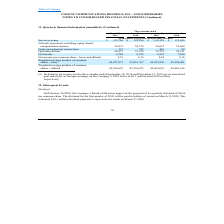From Cogent Communications Group's financial document, What are the respective service revenue at March 31 and June 30, 2018? The document shows two values: $128,706 and $129,296 (in thousands). From the document: "pt share and per share amounts) Service revenue $ 128,706 $ 129,296 $ 130,139 $ 132,049 Network operations, including equity-based compensation expens..." Also, What are the respective service revenue at June 30 and September 30, 2018? The document shows two values: $129,296 and $130,139 (in thousands). From the document: "re amounts) Service revenue $ 128,706 $ 129,296 $ 130,139 $ 132,049 Network operations, including equity-based compensation expense 54,875 54,379 54,6..." Also, What are the respective service revenue at September 30 and December 31, 2018? The document shows two values: $130,139 and $132,049 (in thousands). From the document: "re amounts) Service revenue $ 128,706 $ 129,296 $ 130,139 $ 132,049 Network operations, including equity-based compensation expense 54,875 54,379 54,6..." Also, can you calculate: What is the total service revenue at March 31 and June 30, 2018? Based on the calculation: ($128,706 + $129,296) , the result is 258002 (in thousands). This is based on the information: "pt share and per share amounts) Service revenue $ 128,706 $ 129,296 $ 130,139 $ 132,049 Network operations, including equity-based compensation expense 54,87 nd per share amounts) Service revenue $ 12..." The key data points involved are: 128,706, 129,296. Also, can you calculate: What is the average service revenue at June 30 and September 30, 2018? To answer this question, I need to perform calculations using the financial data. The calculation is: ($129,296 + $130,139)/2 , which equals 129717.5 (in thousands). This is based on the information: "re amounts) Service revenue $ 128,706 $ 129,296 $ 130,139 $ 132,049 Network operations, including equity-based compensation expense 54,875 54,379 54,615 55,6 nd per share amounts) Service revenue $ 12..." The key data points involved are: 129,296, 130,139. Also, can you calculate: What is the percentage change in the service revenue between September 30 and December 31, 2018? To answer this question, I need to perform calculations using the financial data. The calculation is: ($132,049 - $130,139)/$130,139 , which equals 1.47 (percentage). This is based on the information: "re amounts) Service revenue $ 128,706 $ 129,296 $ 130,139 $ 132,049 Network operations, including equity-based compensation expense 54,875 54,379 54,615 55,6 ) Service revenue $ 128,706 $ 129,296 $ 13..." The key data points involved are: 130,139, 132,049. 